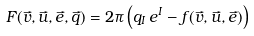<formula> <loc_0><loc_0><loc_500><loc_500>F ( \vec { v } , \vec { u } , \vec { e } , \vec { q } ) = 2 \pi \left ( q _ { I } \, e ^ { I } - f ( \vec { v } , \vec { u } , \vec { e } ) \right )</formula> 